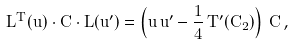<formula> <loc_0><loc_0><loc_500><loc_500>L ^ { T } ( u ) \cdot C \cdot L ( u ^ { \prime } ) = \left ( u \, u ^ { \prime } - \frac { 1 } { 4 } \, T ^ { \prime } ( C _ { 2 } ) \right ) \, C \, ,</formula> 